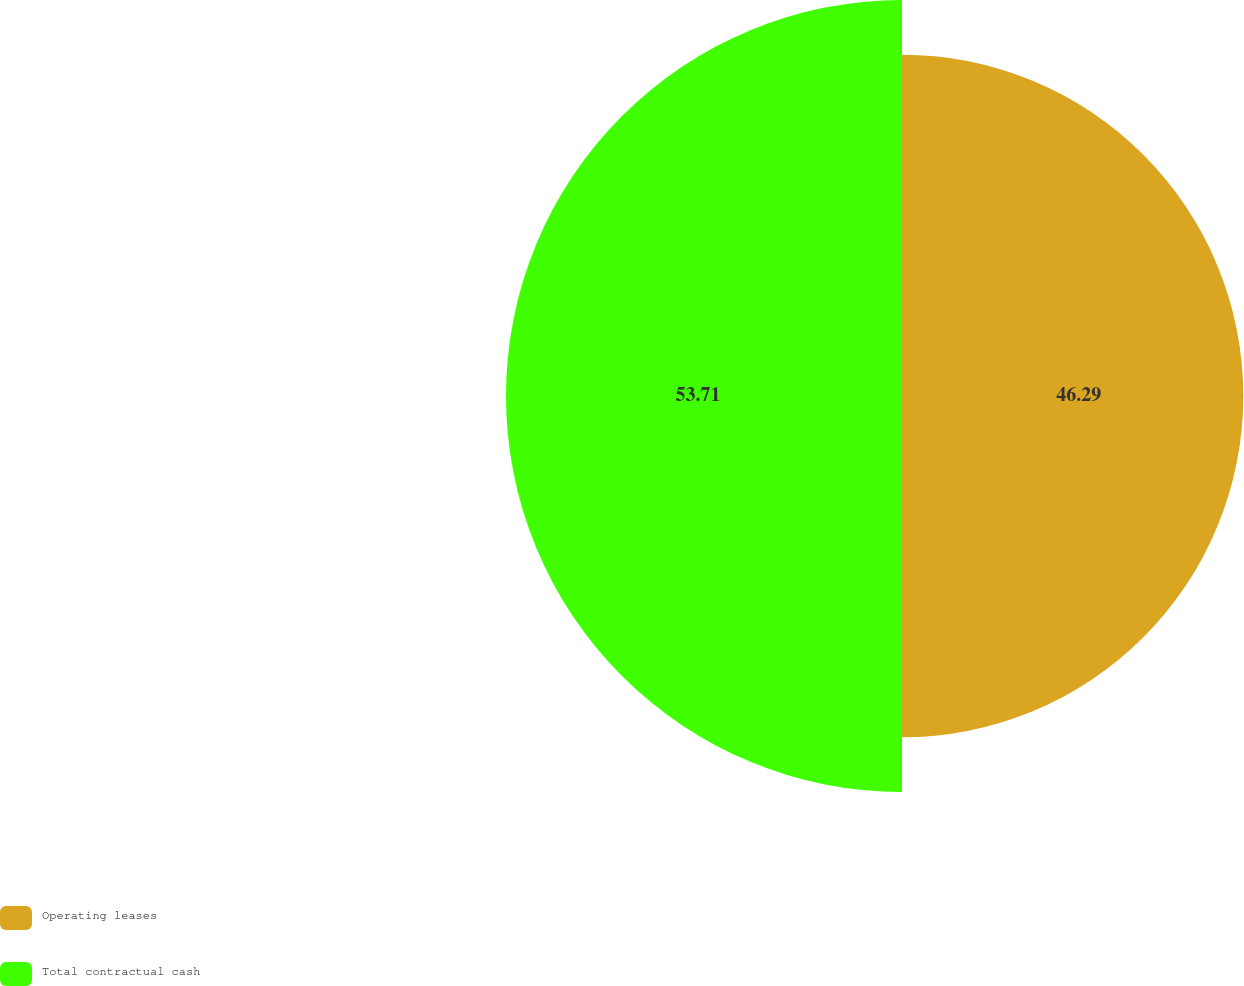Convert chart. <chart><loc_0><loc_0><loc_500><loc_500><pie_chart><fcel>Operating leases<fcel>Total contractual cash<nl><fcel>46.29%<fcel>53.71%<nl></chart> 